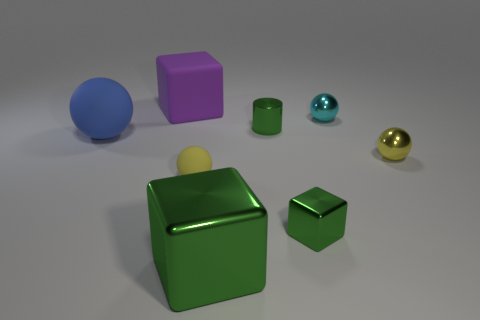Subtract all brown balls. Subtract all blue blocks. How many balls are left? 4 Add 1 big green matte objects. How many objects exist? 9 Subtract all cubes. How many objects are left? 5 Add 5 balls. How many balls exist? 9 Subtract 0 cyan cylinders. How many objects are left? 8 Subtract all big rubber things. Subtract all large gray metallic balls. How many objects are left? 6 Add 8 blue balls. How many blue balls are left? 9 